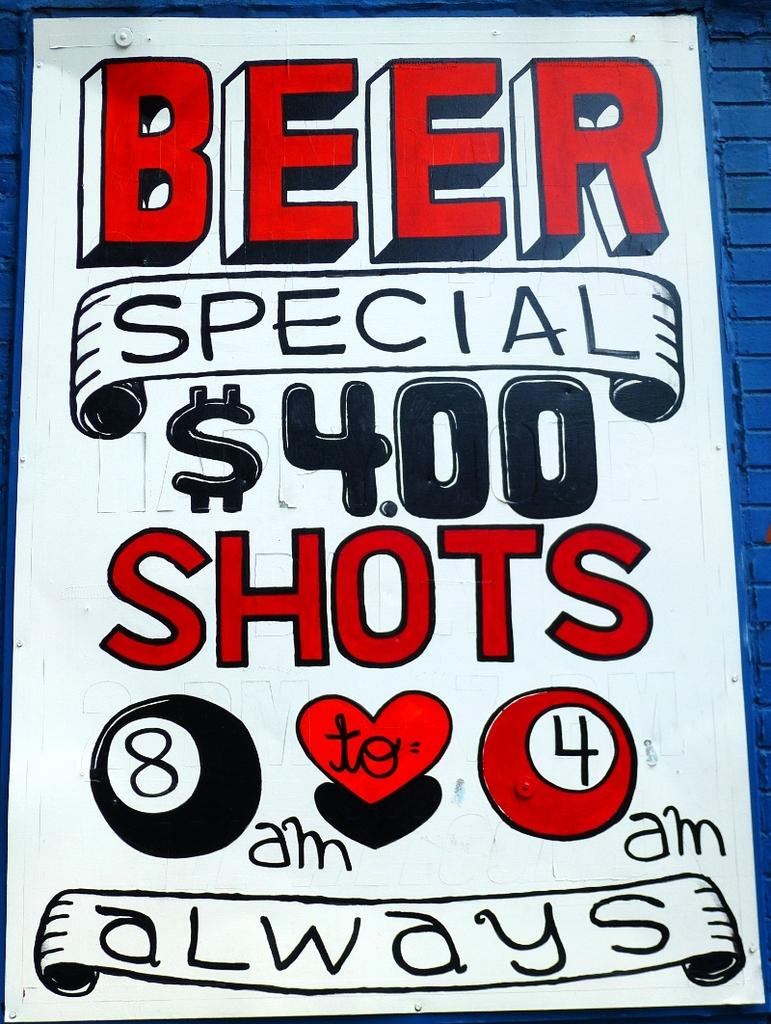<image>
Offer a succinct explanation of the picture presented. A sign advertises four dollar shot specials from 8am to 4am. 